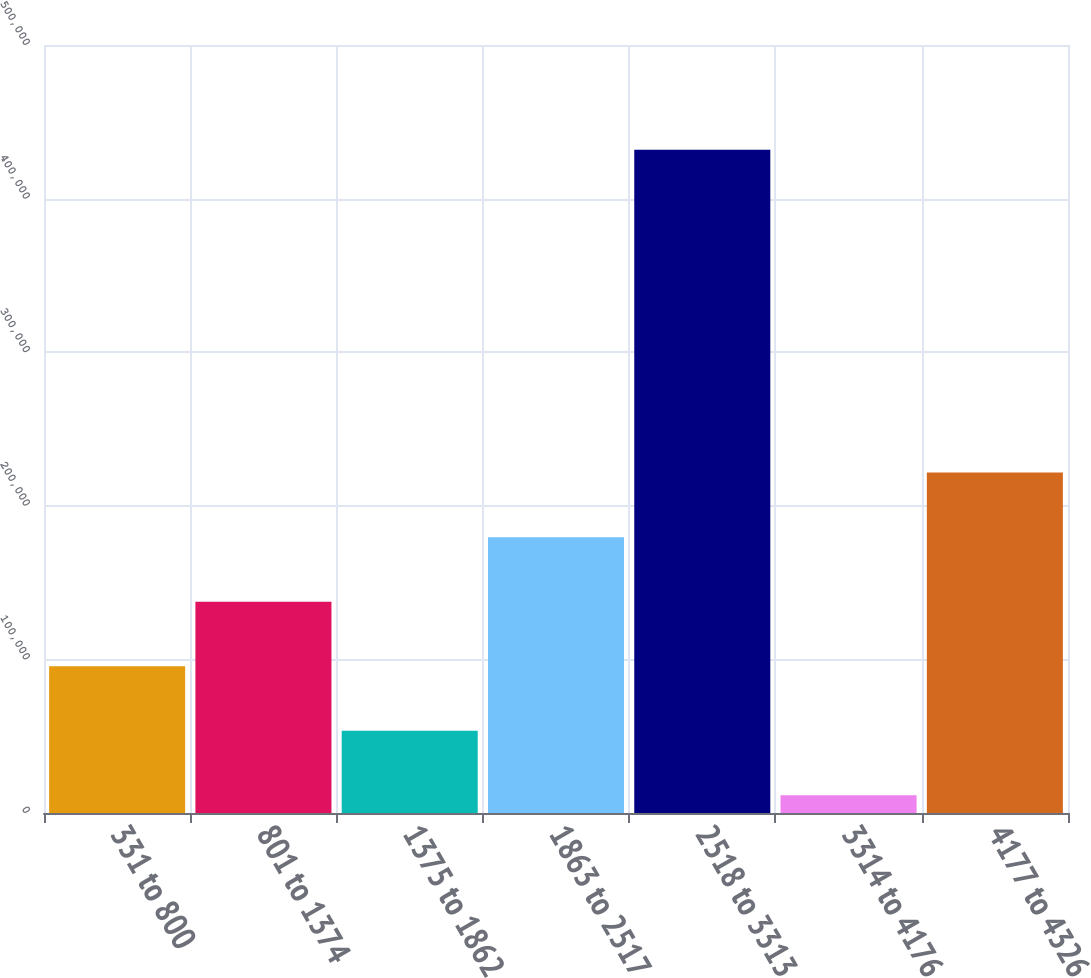Convert chart to OTSL. <chart><loc_0><loc_0><loc_500><loc_500><bar_chart><fcel>331 to 800<fcel>801 to 1374<fcel>1375 to 1862<fcel>1863 to 2517<fcel>2518 to 3313<fcel>3314 to 4176<fcel>4177 to 4326<nl><fcel>95547.8<fcel>137572<fcel>53523.9<fcel>179596<fcel>431739<fcel>11500<fcel>221620<nl></chart> 